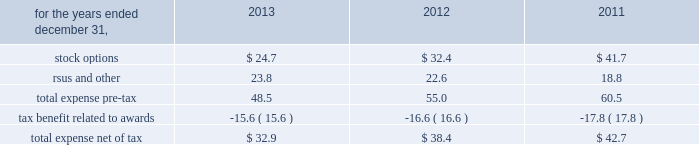Zimmer holdings , inc .
2013 form 10-k annual report notes to consolidated financial statements ( continued ) unrealized gains and losses on cash flow hedges , unrealized gains and losses on available-for-sale securities and amortization of prior service costs and unrecognized gains and losses in actuarial assumptions .
Treasury stock 2013 we account for repurchases of common stock under the cost method and present treasury stock as a reduction of stockholders 2019 equity .
We reissue common stock held in treasury only for limited purposes .
Noncontrolling interest 2013 in 2011 , we made an investment in a company in which we acquired a controlling financial interest , but not 100 percent of the equity .
In 2013 , we purchased additional shares of the company from the minority shareholders .
Further information related to the noncontrolling interests of that investment has not been provided as it is not significant to our consolidated financial statements .
Accounting pronouncements 2013 effective january 1 , 2013 , we adopted the fasb 2019s accounting standard updates ( asus ) requiring reporting of amounts reclassified out of accumulated other comprehensive income ( oci ) and balance sheet offsetting between derivative assets and liabilities .
These asus only change financial statement disclosure requirements and therefore do not impact our financial position , results of operations or cash flows .
See note 12 for disclosures relating to oci .
See note 13 for disclosures relating to balance sheet offsetting .
There are no other recently issued accounting pronouncements that we have not yet adopted that are expected to have a material effect on our financial position , results of operations or cash flows .
Share-based compensation our share-based payments primarily consist of stock options , restricted stock , restricted stock units ( rsus ) , and an employee stock purchase plan .
Share-based compensation expense is as follows ( in millions ) : .
Share-based compensation cost capitalized as part of inventory for the years ended december 31 , 2013 , 2012 and 2011 was $ 4.1 million , $ 6.1 million , and $ 8.8 million , respectively .
As of december 31 , 2013 and 2012 , approximately $ 2.4 million and $ 3.3 million of capitalized costs remained in finished goods inventory .
Stock options we had two equity compensation plans in effect at december 31 , 2013 : the 2009 stock incentive plan ( 2009 plan ) and the stock plan for non-employee directors .
The 2009 plan succeeded the 2006 stock incentive plan ( 2006 plan ) and the teamshare stock option plan ( teamshare plan ) .
No further awards have been granted under the 2006 plan or under the teamshare plan since may 2009 , and shares remaining available for grant under those plans have been merged into the 2009 plan .
Vested and unvested stock options and unvested restricted stock and rsus previously granted under the 2006 plan , the teamshare plan and another prior plan , the 2001 stock incentive plan , remained outstanding as of december 31 , 2013 .
We have reserved the maximum number of shares of common stock available for award under the terms of each of these plans .
We have registered 57.9 million shares of common stock under these plans .
The 2009 plan provides for the grant of nonqualified stock options and incentive stock options , long-term performance awards in the form of performance shares or units , restricted stock , rsus and stock appreciation rights .
The compensation and management development committee of the board of directors determines the grant date for annual grants under our equity compensation plans .
The date for annual grants under the 2009 plan to our executive officers is expected to occur in the first quarter of each year following the earnings announcements for the previous quarter and full year .
The stock plan for non-employee directors provides for awards of stock options , restricted stock and rsus to non-employee directors .
It has been our practice to issue shares of common stock upon exercise of stock options from previously unissued shares , except in limited circumstances where they are issued from treasury stock .
The total number of awards which may be granted in a given year and/or over the life of the plan under each of our equity compensation plans is limited .
At december 31 , 2013 , an aggregate of 10.4 million shares were available for future grants and awards under these plans .
Stock options granted to date under our plans generally vest over four years and generally have a maximum contractual life of 10 years .
As established under our equity compensation plans , vesting may accelerate upon retirement after the first anniversary date of the award if certain criteria are met .
We recognize expense related to stock options on a straight-line basis over the requisite service period , less awards expected to be forfeited using estimated forfeiture rates .
Due to the accelerated retirement provisions , the requisite service period of our stock options range from one to four years .
Stock options are granted with an exercise price equal to the market price of our common stock on the date of grant , except in limited circumstances where local law may dictate otherwise. .
What was the percentage change in share-based compensation expense between 2012 and 2013? 
Computations: ((32.9 - 38.4) / 38.4)
Answer: -0.14323. 